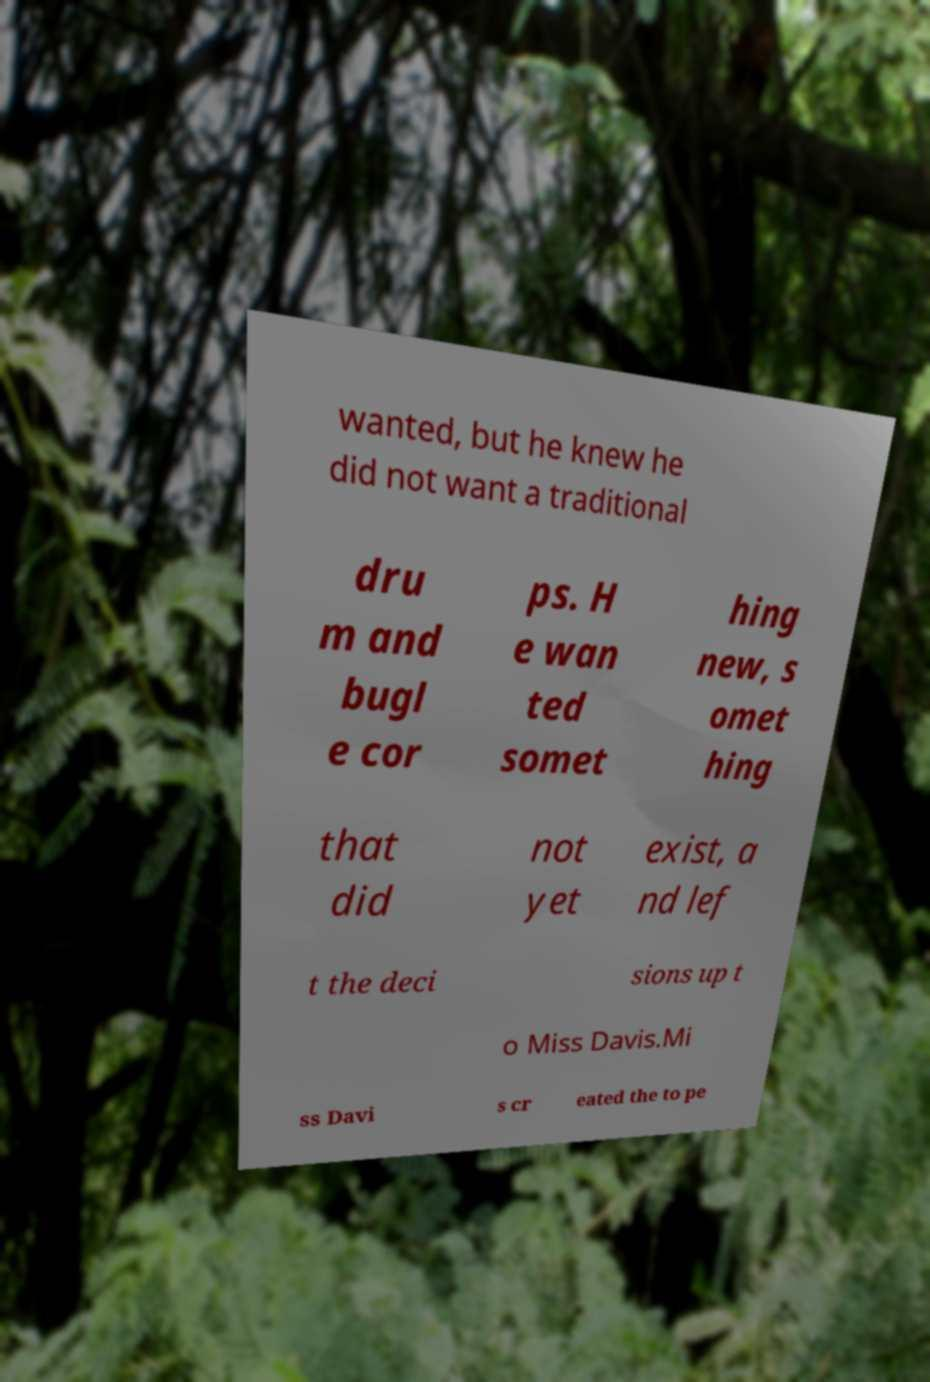Can you accurately transcribe the text from the provided image for me? wanted, but he knew he did not want a traditional dru m and bugl e cor ps. H e wan ted somet hing new, s omet hing that did not yet exist, a nd lef t the deci sions up t o Miss Davis.Mi ss Davi s cr eated the to pe 